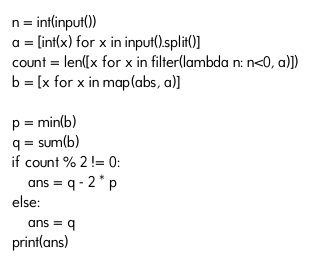<code> <loc_0><loc_0><loc_500><loc_500><_Python_>n = int(input())
a = [int(x) for x in input().split()]
count = len([x for x in filter(lambda n: n<0, a)])
b = [x for x in map(abs, a)]

p = min(b)
q = sum(b)
if count % 2 != 0:
    ans = q - 2 * p
else:
    ans = q
print(ans)</code> 